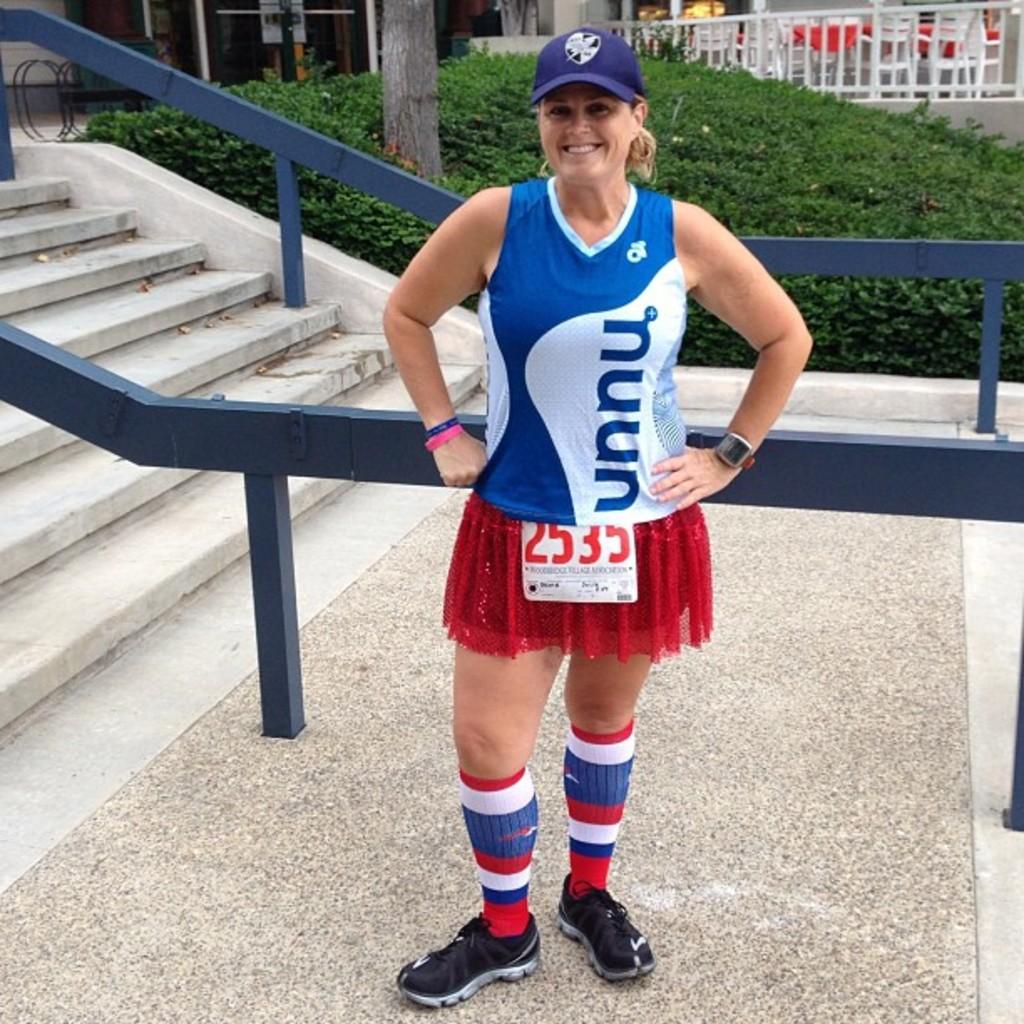What is the main subject of the image? There is a person in the image. What architectural feature is present in the image? There are stairs in the image. What safety feature is present near the stairs? There is a railing in the image. What type of natural environment is visible in the image? There is grass and a tree in the image. What type of flooring is present in the image? There is a floor in the image. What type of furniture is present in the image? There are chairs and a table in the image. What type of location is visible in the image? There are stores visible in the image. How many quarters are visible on the person's head in the image? There are no quarters visible on the person's head in the image. What type of birds can be seen flying in the image? There are no birds visible in the image. 